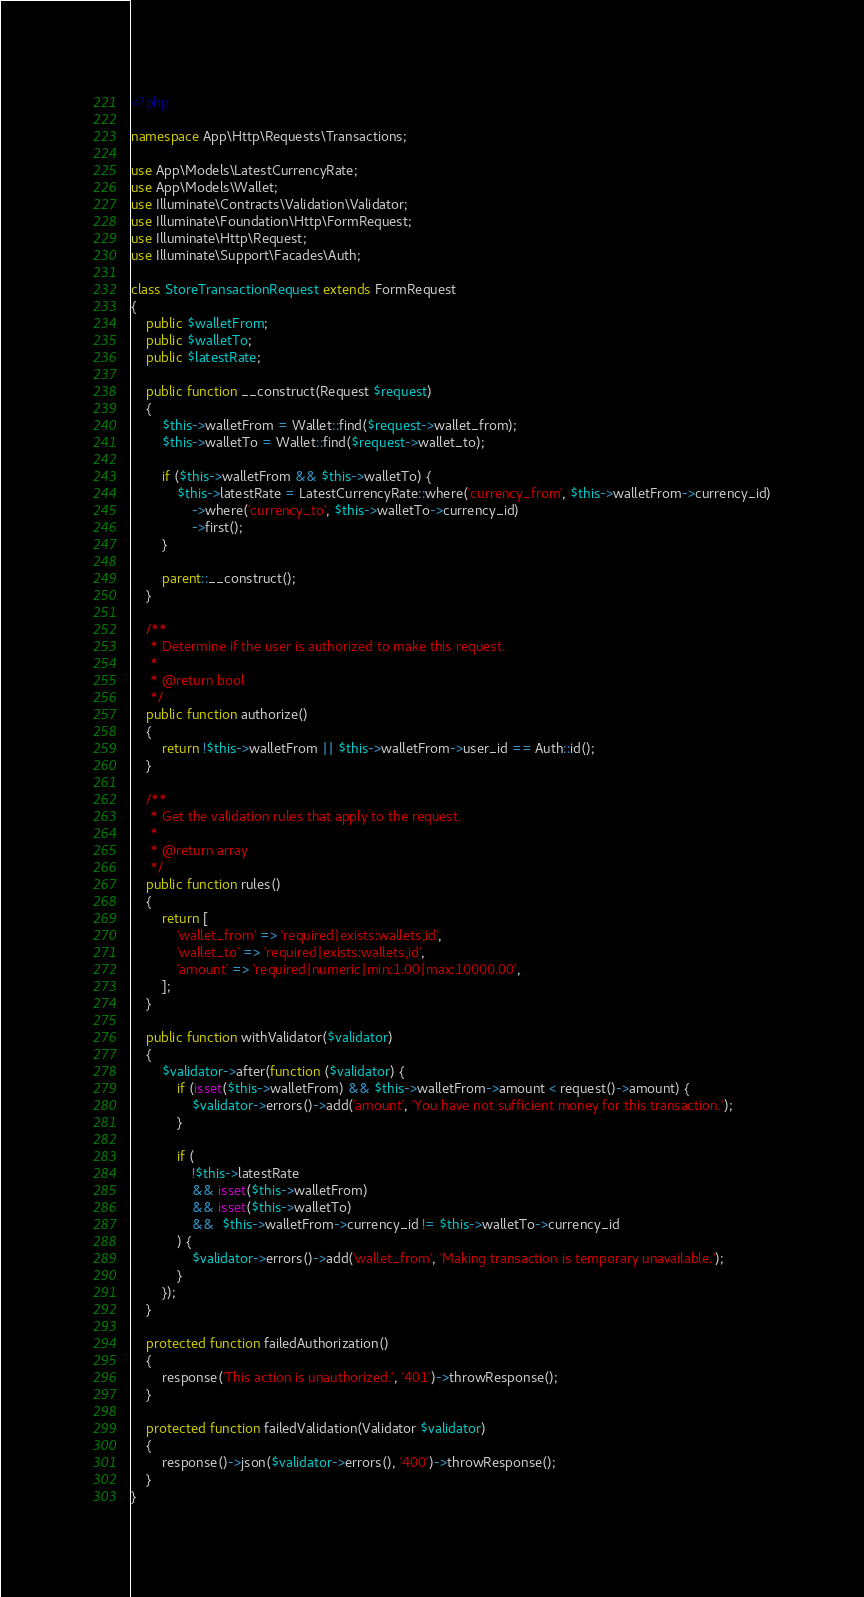Convert code to text. <code><loc_0><loc_0><loc_500><loc_500><_PHP_><?php

namespace App\Http\Requests\Transactions;

use App\Models\LatestCurrencyRate;
use App\Models\Wallet;
use Illuminate\Contracts\Validation\Validator;
use Illuminate\Foundation\Http\FormRequest;
use Illuminate\Http\Request;
use Illuminate\Support\Facades\Auth;

class StoreTransactionRequest extends FormRequest
{
    public $walletFrom;
    public $walletTo;
    public $latestRate;

    public function __construct(Request $request)
    {
        $this->walletFrom = Wallet::find($request->wallet_from);
        $this->walletTo = Wallet::find($request->wallet_to);

        if ($this->walletFrom && $this->walletTo) {
            $this->latestRate = LatestCurrencyRate::where('currency_from', $this->walletFrom->currency_id)
                ->where('currency_to', $this->walletTo->currency_id)
                ->first();
        }

        parent::__construct();
    }

    /**
     * Determine if the user is authorized to make this request.
     *
     * @return bool
     */
    public function authorize()
    {
        return !$this->walletFrom || $this->walletFrom->user_id == Auth::id();
    }

    /**
     * Get the validation rules that apply to the request.
     *
     * @return array
     */
    public function rules()
    {
        return [
            'wallet_from' => 'required|exists:wallets,id',
            'wallet_to' => 'required|exists:wallets,id',
            'amount' => 'required|numeric|min:1.00|max:10000.00',
        ];
    }

    public function withValidator($validator)
    {
        $validator->after(function ($validator) {
            if (isset($this->walletFrom) && $this->walletFrom->amount < request()->amount) {
                $validator->errors()->add('amount', 'You have not sufficient money for this transaction.');
            }

            if (
                !$this->latestRate
                && isset($this->walletFrom)
                && isset($this->walletTo)
                &&  $this->walletFrom->currency_id != $this->walletTo->currency_id
            ) {
                $validator->errors()->add('wallet_from', 'Making transaction is temporary unavailable.');
            }
        });
    }

    protected function failedAuthorization()
    {
        response('This action is unauthorized.', '401')->throwResponse();
    }

    protected function failedValidation(Validator $validator)
    {
        response()->json($validator->errors(), '400')->throwResponse();
    }
}
</code> 